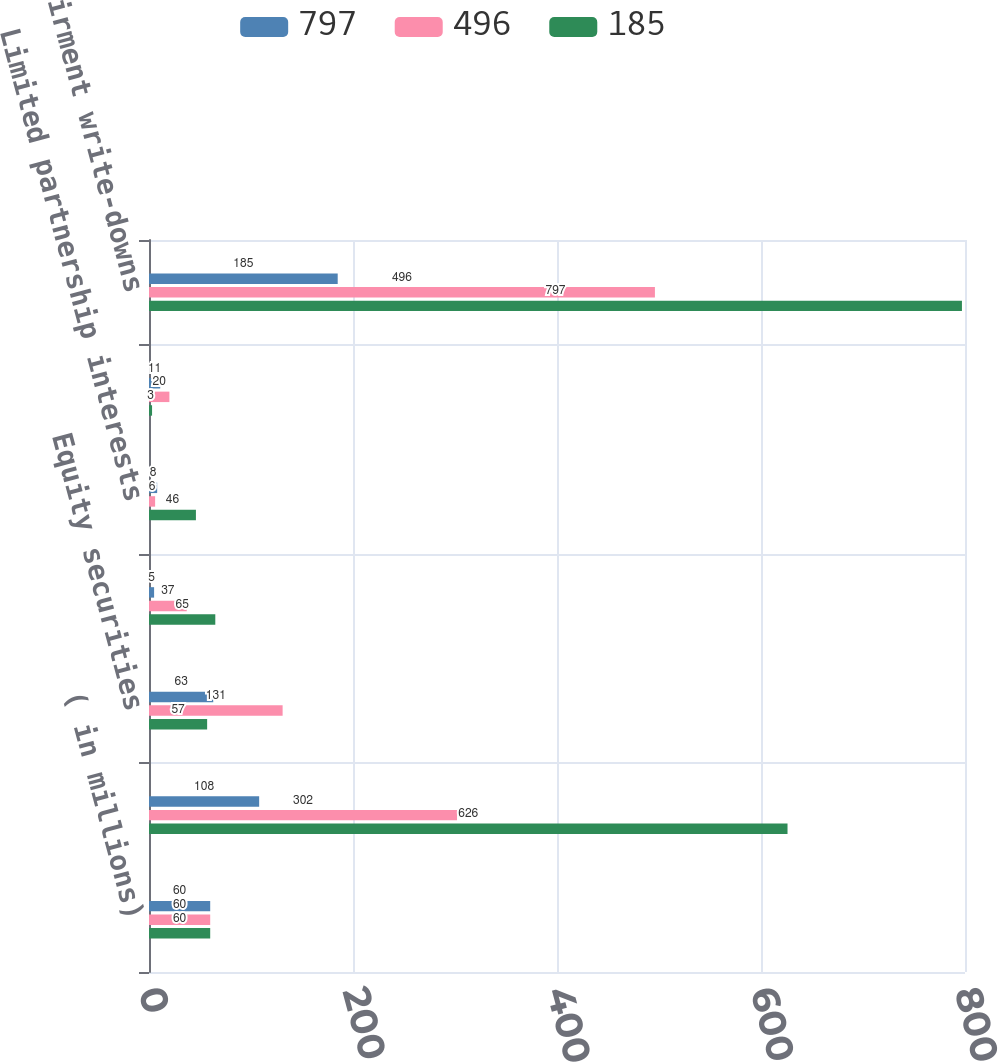Convert chart. <chart><loc_0><loc_0><loc_500><loc_500><stacked_bar_chart><ecel><fcel>( in millions)<fcel>Fixed income securities<fcel>Equity securities<fcel>Mortgage loans<fcel>Limited partnership interests<fcel>Other investments<fcel>Impairment write-downs<nl><fcel>797<fcel>60<fcel>108<fcel>63<fcel>5<fcel>8<fcel>11<fcel>185<nl><fcel>496<fcel>60<fcel>302<fcel>131<fcel>37<fcel>6<fcel>20<fcel>496<nl><fcel>185<fcel>60<fcel>626<fcel>57<fcel>65<fcel>46<fcel>3<fcel>797<nl></chart> 